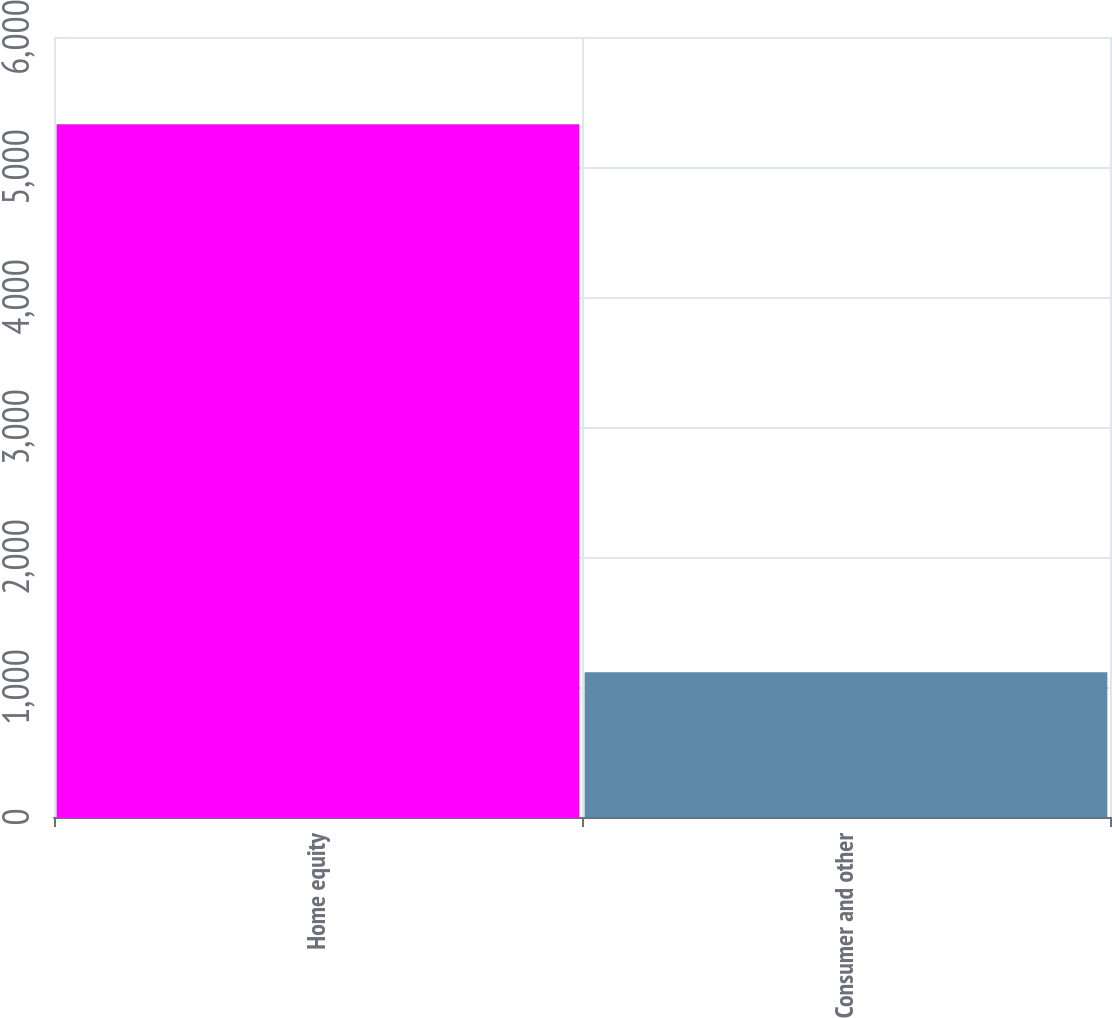Convert chart to OTSL. <chart><loc_0><loc_0><loc_500><loc_500><bar_chart><fcel>Home equity<fcel>Consumer and other<nl><fcel>5328.7<fcel>1113.2<nl></chart> 